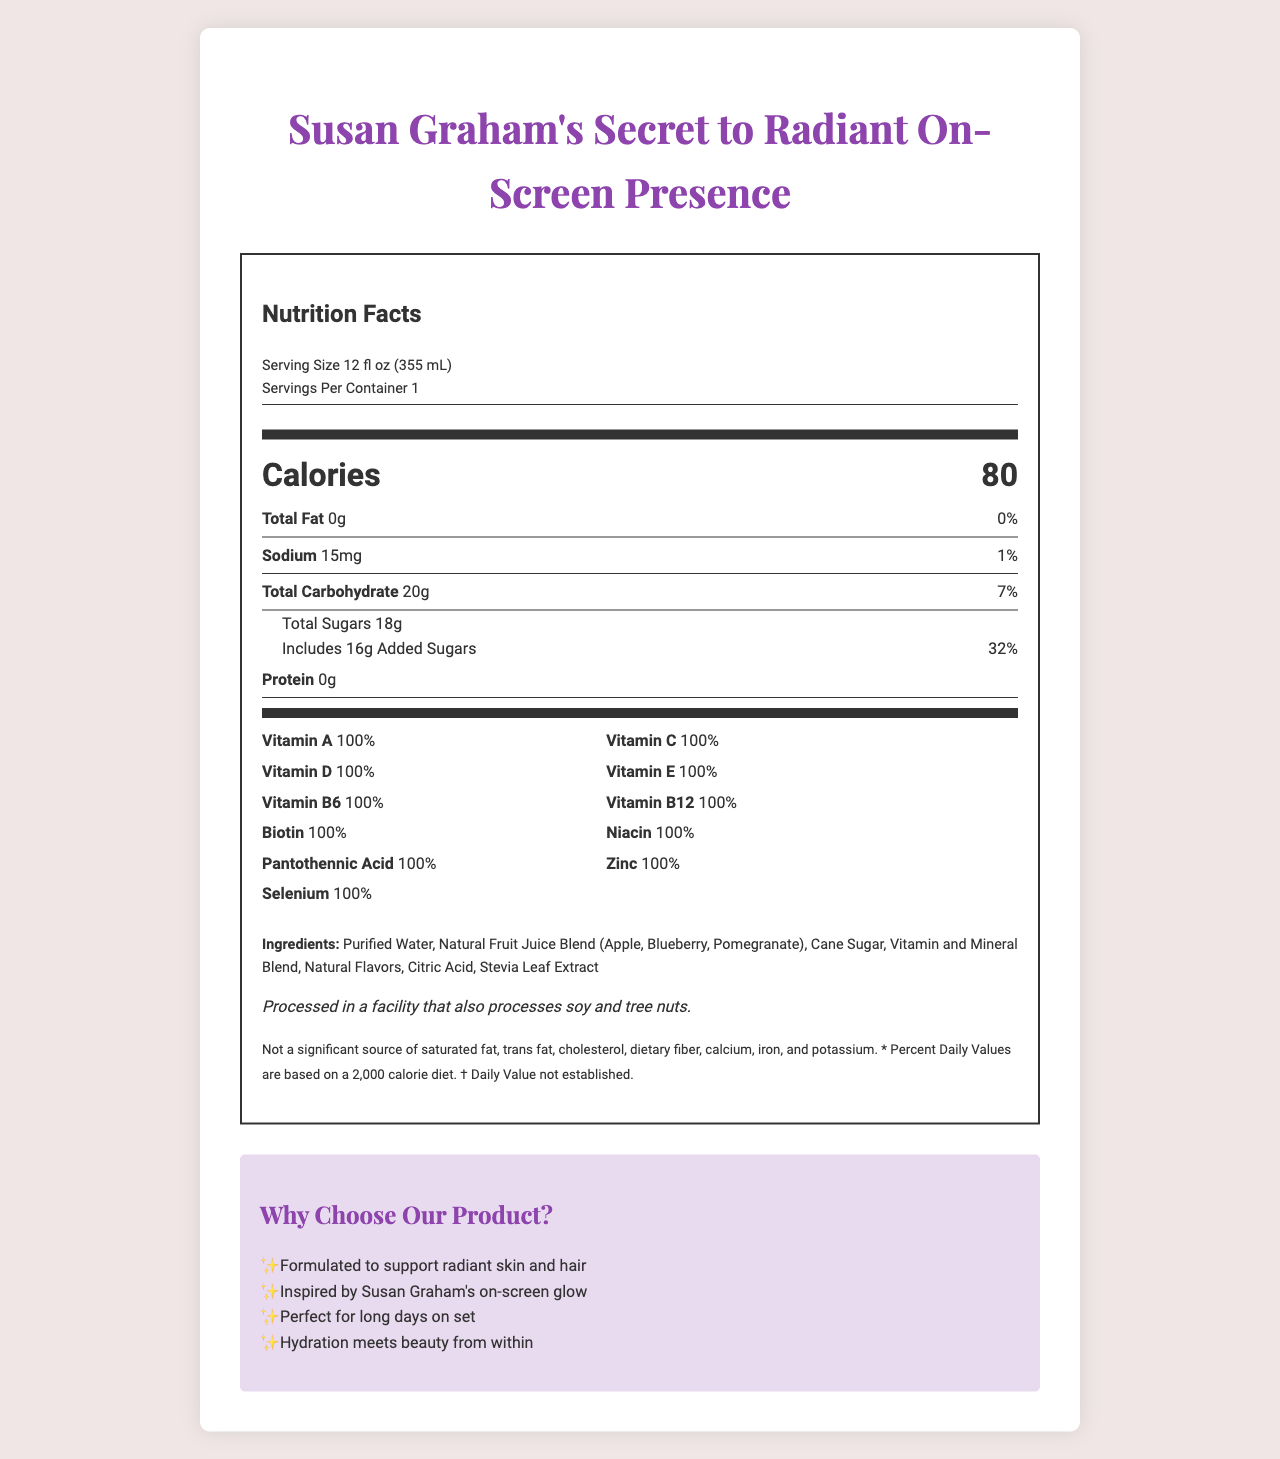what is the serving size? The serving size is indicated in the "Serving Size" information at the top of the nutrition label.
Answer: 12 fl oz (355 mL) how many calories are in one serving? The number of calories per serving is shown in the "Calories" section of the label.
Answer: 80 what percentage of daily value is the added sugars? The percentage of daily value is shown next to the added sugars amount in the "Includes Added Sugars" part of the label.
Answer: 32% how much vitamin C does this beverage contain per serving? The amount of vitamin C per serving is listed in the vitamins section of the label.
Answer: 90mg what is the amount of sodium in one serving? The amount of sodium per serving is listed under the "Sodium" section on the label.
Answer: 15mg which of the following vitamins have a daily value of 100% in this beverage? A. Vitamin C B. Niacin C. Vitamin B6 D. All of the above Each of these vitamins—Vitamin C, Niacin, and Vitamin B6—have a daily value of 100% as shown in the vitamins section.
Answer: D. All of the above how many grams of total carbohydrates are in one serving? A. 10g B. 20g C. 25g The total amount of carbohydrates per serving is listed under the "Total Carbohydrate" section on the label.
Answer: B. 20g is there any protein in this beverage? The protein content is listed as 0g in the "Protein" section on the label.
Answer: No is this product a significant source of calcium? The label includes a disclaimer stating that it is "Not a significant source of saturated fat, trans fat, cholesterol, dietary fiber, calcium, iron, and potassium."
Answer: No what type of facility processes this beverage? The allergen information specifies that the beverage is processed in a facility that also processes soy and tree nuts.
Answer: A facility that processes soy and tree nuts summarize the main idea of the document The description given captures the overall content of the document in terms of nutrition information, ingredients, allergen information, and marketing claims related to the beverage.
Answer: The document is a nutrition facts label for "Susan Graham's Secret to Radiant On-Screen Presence", a vitamin-fortified beverage. It details the serving size, nutritional content, ingredients, allergen information, disclaimers, and marketing claims. The beverage provides 80 calories per serving and is rich in various vitamins, each providing 100% of the daily value. It is low in sodium, fat, and protein but contains 20g of carbohydrates and 18g of total sugars. The product is marketed as promoting radiant skin and hair, inspired by Susan Graham's on-screen glow. what is the source of sweetener used apart from cane sugar? Stevia Leaf Extract is listed among the ingredients as an additional sweetener apart from cane sugar.
Answer: Stevia Leaf Extract how many vitamins are included in the ingredient list? The vitamins listed in the document are: Vitamin A, Vitamin C, Vitamin D, Vitamin E, Vitamin B6, Vitamin B12, Biotin, Niacin, Pantothenic Acid, Zinc, and Selenium.
Answer: 11 is the nutrient content the same for each serving size? The document specifies nutritional values per serving size, indicating that each serving contains the same nutrient content.
Answer: Yes what is the combined daily value percentage of all vitamins in one serving? Each of the 10 vitamins listed (Vitamin A, Vitamin C, Vitamin D, Vitamin E, Vitamin B6, Vitamin B12, Biotin, Niacin, Pantothenic Acid, Zinc, and Selenium) contributes 100% of the daily value, summing up to 1000%.
Answer: 1000% what quantity of calcium is present in one serving? The label explicitly states that it is not a significant source of calcium, and no specific quantity is given.
Answer: Not enough information 